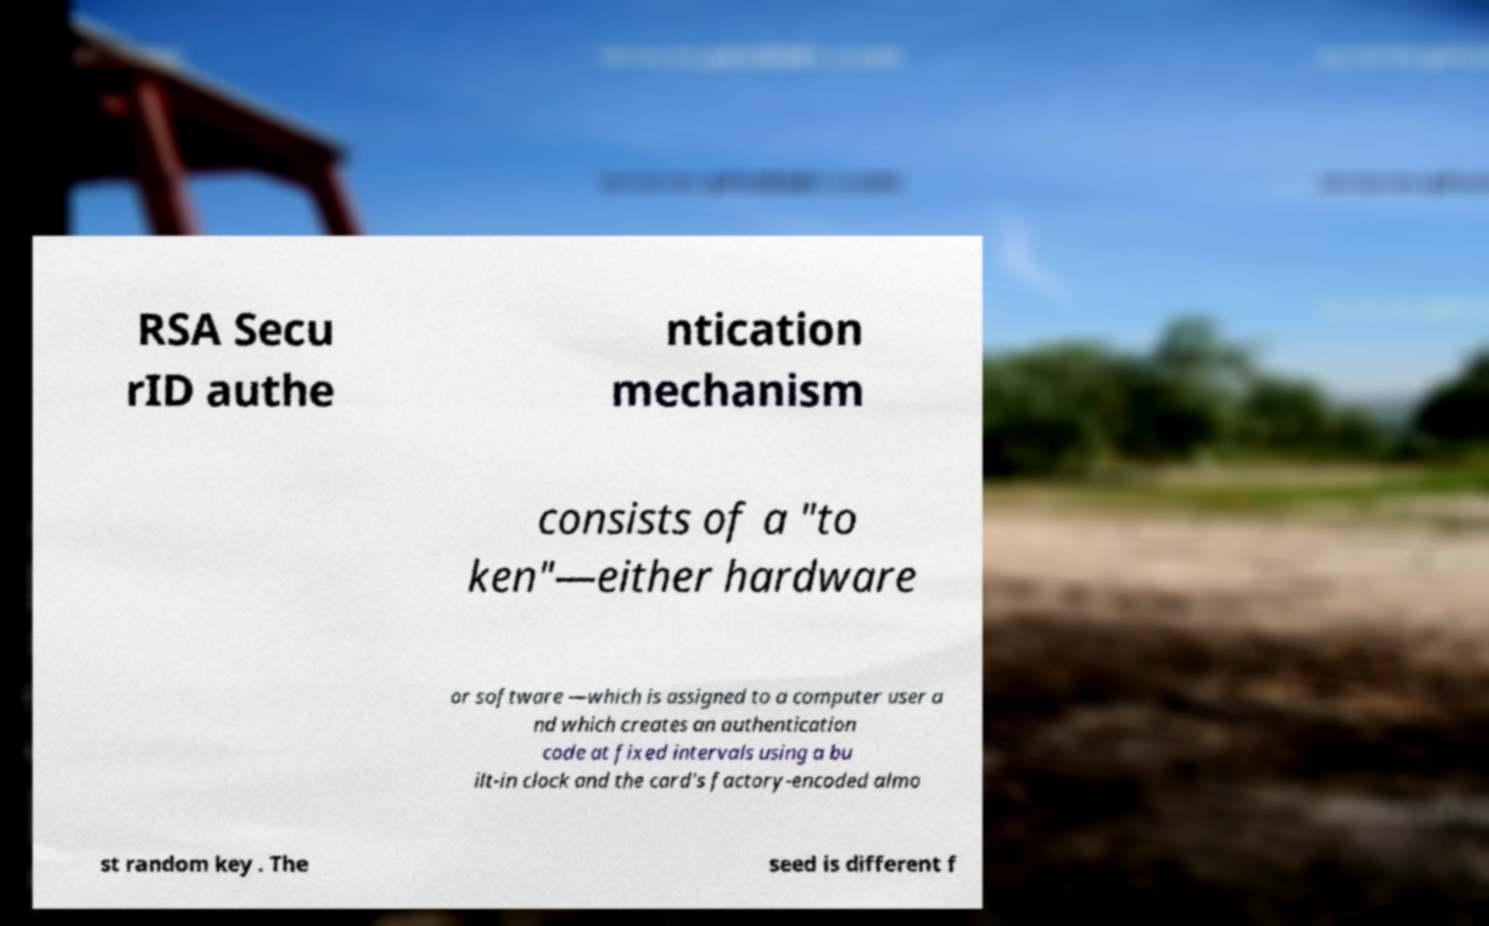For documentation purposes, I need the text within this image transcribed. Could you provide that? RSA Secu rID authe ntication mechanism consists of a "to ken"—either hardware or software —which is assigned to a computer user a nd which creates an authentication code at fixed intervals using a bu ilt-in clock and the card's factory-encoded almo st random key . The seed is different f 